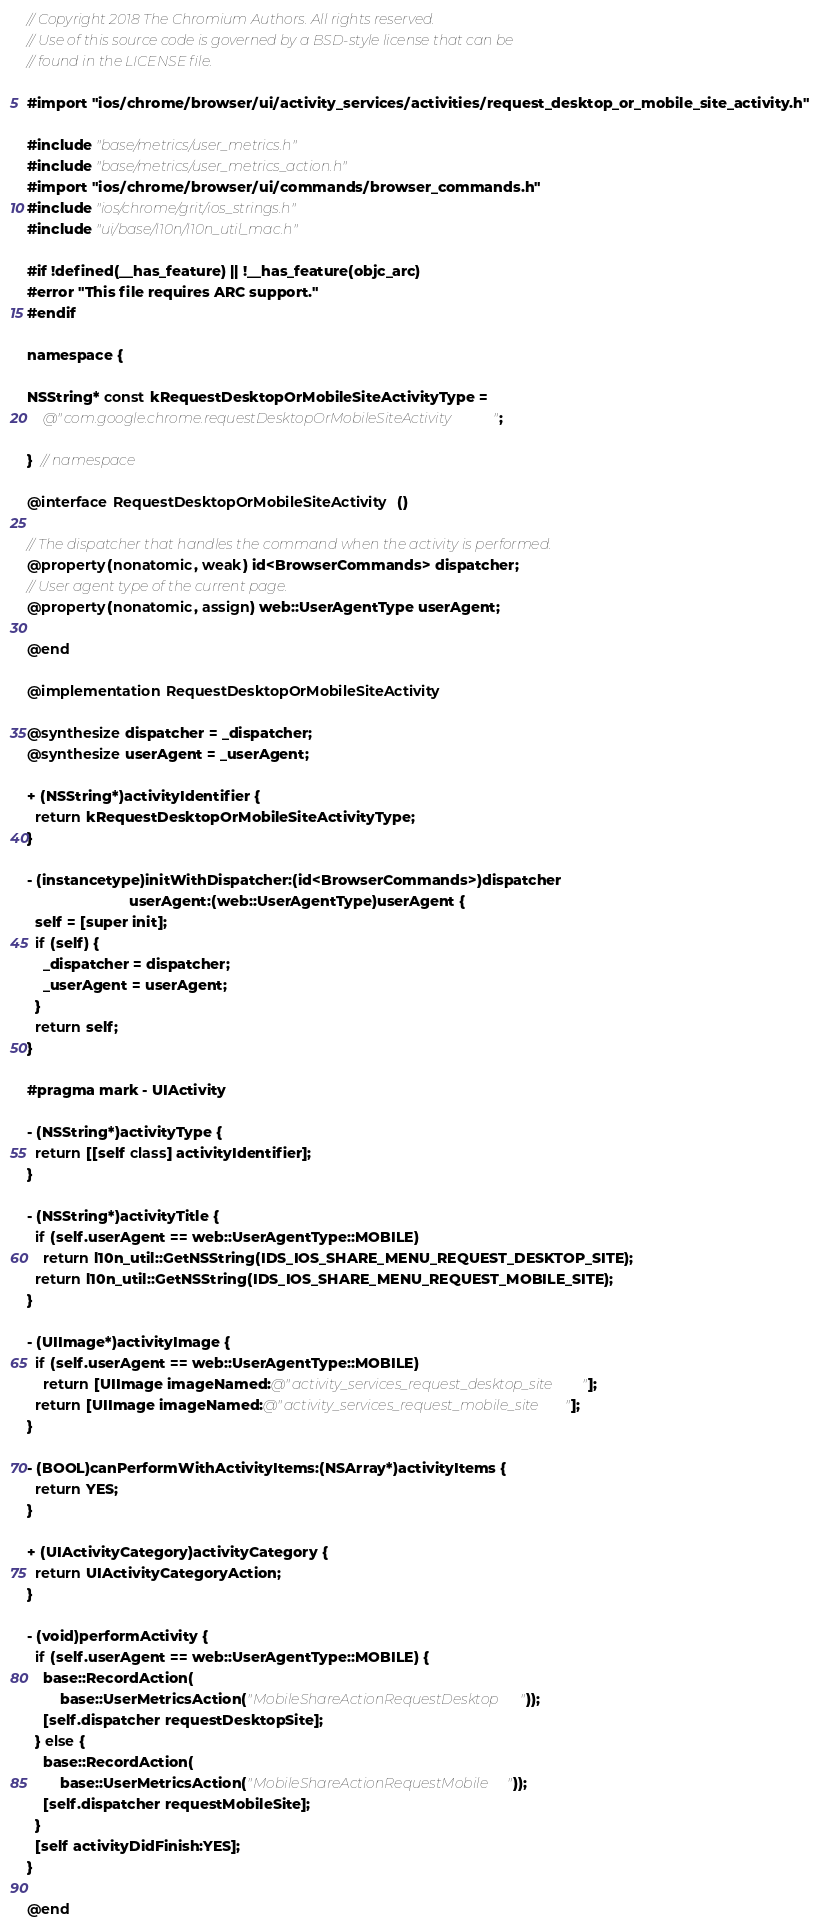<code> <loc_0><loc_0><loc_500><loc_500><_ObjectiveC_>// Copyright 2018 The Chromium Authors. All rights reserved.
// Use of this source code is governed by a BSD-style license that can be
// found in the LICENSE file.

#import "ios/chrome/browser/ui/activity_services/activities/request_desktop_or_mobile_site_activity.h"

#include "base/metrics/user_metrics.h"
#include "base/metrics/user_metrics_action.h"
#import "ios/chrome/browser/ui/commands/browser_commands.h"
#include "ios/chrome/grit/ios_strings.h"
#include "ui/base/l10n/l10n_util_mac.h"

#if !defined(__has_feature) || !__has_feature(objc_arc)
#error "This file requires ARC support."
#endif

namespace {

NSString* const kRequestDesktopOrMobileSiteActivityType =
    @"com.google.chrome.requestDesktopOrMobileSiteActivity";

}  // namespace

@interface RequestDesktopOrMobileSiteActivity ()

// The dispatcher that handles the command when the activity is performed.
@property(nonatomic, weak) id<BrowserCommands> dispatcher;
// User agent type of the current page.
@property(nonatomic, assign) web::UserAgentType userAgent;

@end

@implementation RequestDesktopOrMobileSiteActivity

@synthesize dispatcher = _dispatcher;
@synthesize userAgent = _userAgent;

+ (NSString*)activityIdentifier {
  return kRequestDesktopOrMobileSiteActivityType;
}

- (instancetype)initWithDispatcher:(id<BrowserCommands>)dispatcher
                         userAgent:(web::UserAgentType)userAgent {
  self = [super init];
  if (self) {
    _dispatcher = dispatcher;
    _userAgent = userAgent;
  }
  return self;
}

#pragma mark - UIActivity

- (NSString*)activityType {
  return [[self class] activityIdentifier];
}

- (NSString*)activityTitle {
  if (self.userAgent == web::UserAgentType::MOBILE)
    return l10n_util::GetNSString(IDS_IOS_SHARE_MENU_REQUEST_DESKTOP_SITE);
  return l10n_util::GetNSString(IDS_IOS_SHARE_MENU_REQUEST_MOBILE_SITE);
}

- (UIImage*)activityImage {
  if (self.userAgent == web::UserAgentType::MOBILE)
    return [UIImage imageNamed:@"activity_services_request_desktop_site"];
  return [UIImage imageNamed:@"activity_services_request_mobile_site"];
}

- (BOOL)canPerformWithActivityItems:(NSArray*)activityItems {
  return YES;
}

+ (UIActivityCategory)activityCategory {
  return UIActivityCategoryAction;
}

- (void)performActivity {
  if (self.userAgent == web::UserAgentType::MOBILE) {
    base::RecordAction(
        base::UserMetricsAction("MobileShareActionRequestDesktop"));
    [self.dispatcher requestDesktopSite];
  } else {
    base::RecordAction(
        base::UserMetricsAction("MobileShareActionRequestMobile"));
    [self.dispatcher requestMobileSite];
  }
  [self activityDidFinish:YES];
}

@end
</code> 